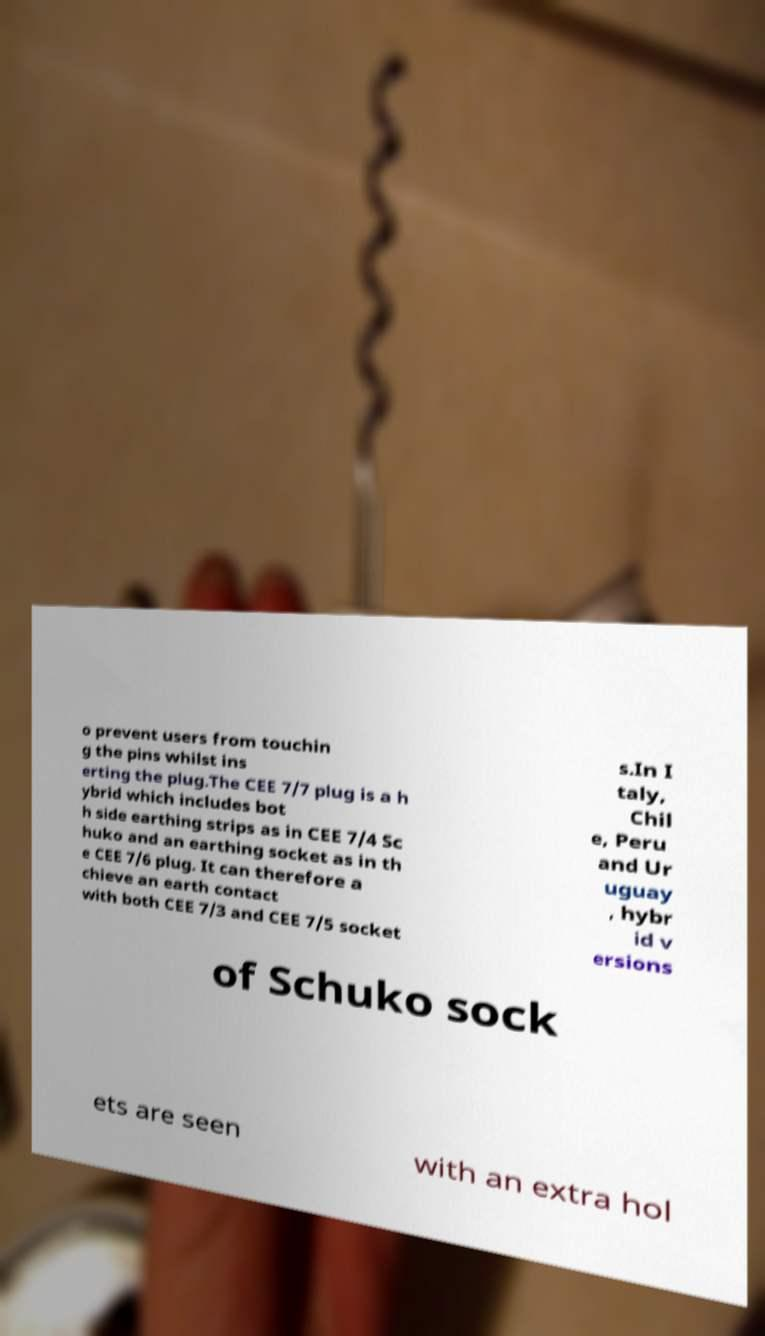Can you read and provide the text displayed in the image?This photo seems to have some interesting text. Can you extract and type it out for me? o prevent users from touchin g the pins whilst ins erting the plug.The CEE 7/7 plug is a h ybrid which includes bot h side earthing strips as in CEE 7/4 Sc huko and an earthing socket as in th e CEE 7/6 plug. It can therefore a chieve an earth contact with both CEE 7/3 and CEE 7/5 socket s.In I taly, Chil e, Peru and Ur uguay , hybr id v ersions of Schuko sock ets are seen with an extra hol 